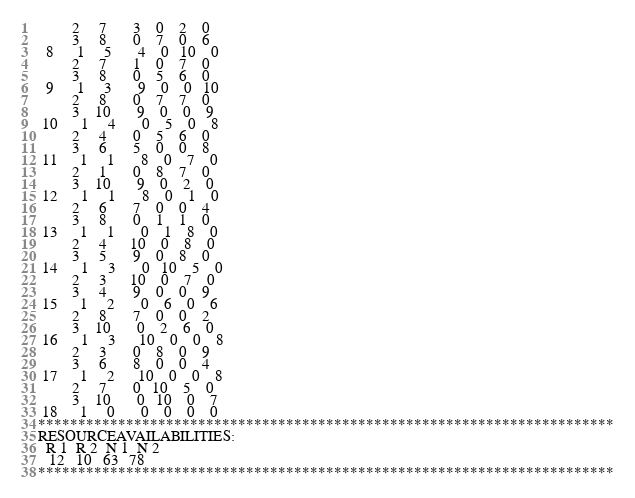<code> <loc_0><loc_0><loc_500><loc_500><_ObjectiveC_>         2     7       3    0    2    0
         3     8       0    7    0    6
  8      1     5       4    0   10    0
         2     7       1    0    7    0
         3     8       0    5    6    0
  9      1     3       9    0    0   10
         2     8       0    7    7    0
         3    10       9    0    0    9
 10      1     4       0    5    0    8
         2     4       0    5    6    0
         3     6       5    0    0    8
 11      1     1       8    0    7    0
         2     1       0    8    7    0
         3    10       9    0    2    0
 12      1     1       8    0    1    0
         2     6       7    0    0    4
         3     8       0    1    1    0
 13      1     1       0    1    8    0
         2     4      10    0    8    0
         3     5       9    0    8    0
 14      1     3       0   10    5    0
         2     3      10    0    7    0
         3     4       9    0    0    9
 15      1     2       0    6    0    6
         2     8       7    0    0    2
         3    10       0    2    6    0
 16      1     3      10    0    0    8
         2     3       0    8    0    9
         3     6       8    0    0    4
 17      1     2      10    0    0    8
         2     7       0   10    5    0
         3    10       0   10    0    7
 18      1     0       0    0    0    0
************************************************************************
RESOURCEAVAILABILITIES:
  R 1  R 2  N 1  N 2
   12   10   63   78
************************************************************************
</code> 